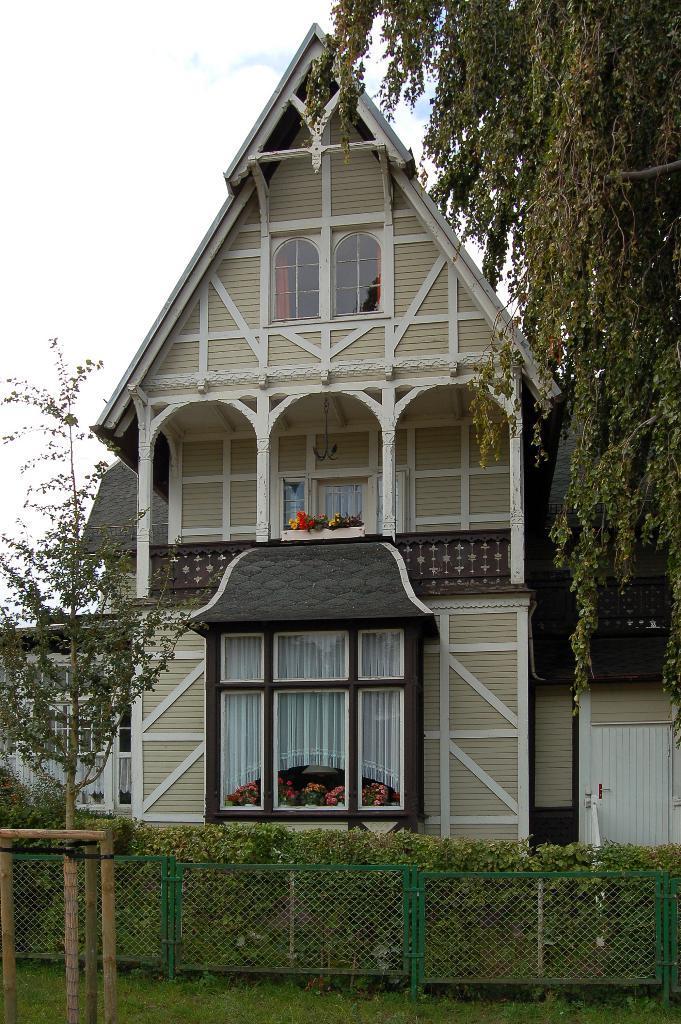In one or two sentences, can you explain what this image depicts? In the center of the image we can see a house. At the bottom of the image we can see fencing, plants and grass. In the background there is sky and clouds. 